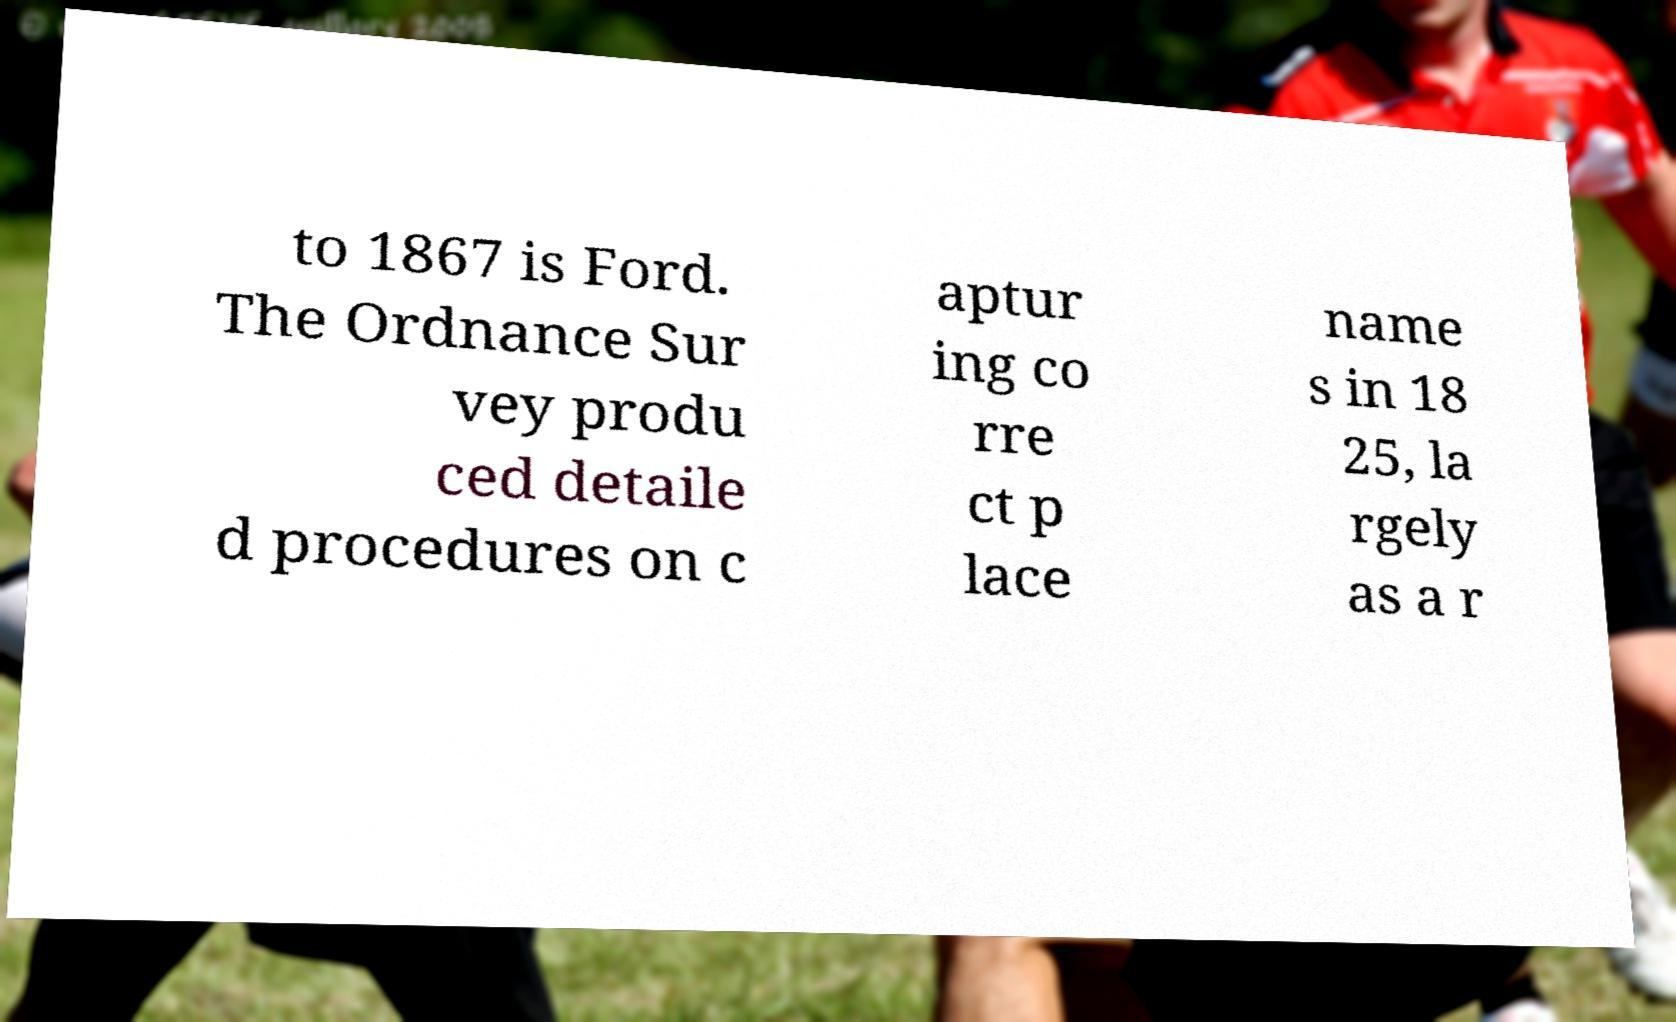Can you read and provide the text displayed in the image?This photo seems to have some interesting text. Can you extract and type it out for me? to 1867 is Ford. The Ordnance Sur vey produ ced detaile d procedures on c aptur ing co rre ct p lace name s in 18 25, la rgely as a r 